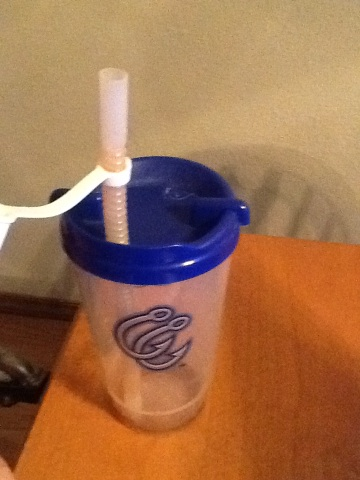What is the logo on the mug? The logo on the mug features an abstract design incorporating what appears to be swirls or stylized script, predominantly in blue. 